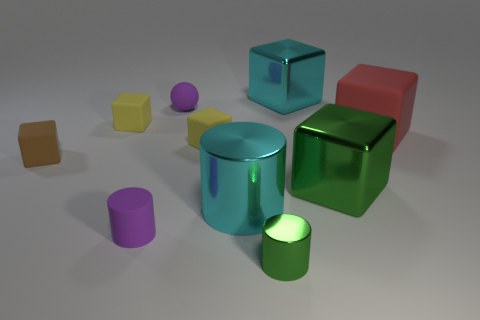What number of things are in front of the big green shiny object and behind the small metallic object?
Make the answer very short. 2. How many blue objects are either big metal cylinders or small spheres?
Provide a short and direct response. 0. Does the small thing that is in front of the small matte cylinder have the same color as the large metallic thing behind the large red block?
Provide a succinct answer. No. The large block that is behind the matte cube right of the large cyan metallic thing right of the big cylinder is what color?
Offer a very short reply. Cyan. There is a small purple matte thing that is behind the brown object; are there any yellow matte cubes behind it?
Give a very brief answer. No. Does the object behind the small matte ball have the same shape as the small shiny thing?
Provide a short and direct response. No. Is there any other thing that has the same shape as the tiny green shiny object?
Provide a succinct answer. Yes. What number of blocks are cyan metallic things or tiny purple rubber things?
Your answer should be very brief. 1. What number of big cyan metal objects are there?
Offer a very short reply. 2. There is a rubber object that is on the right side of the cyan metal object in front of the brown matte object; how big is it?
Give a very brief answer. Large. 